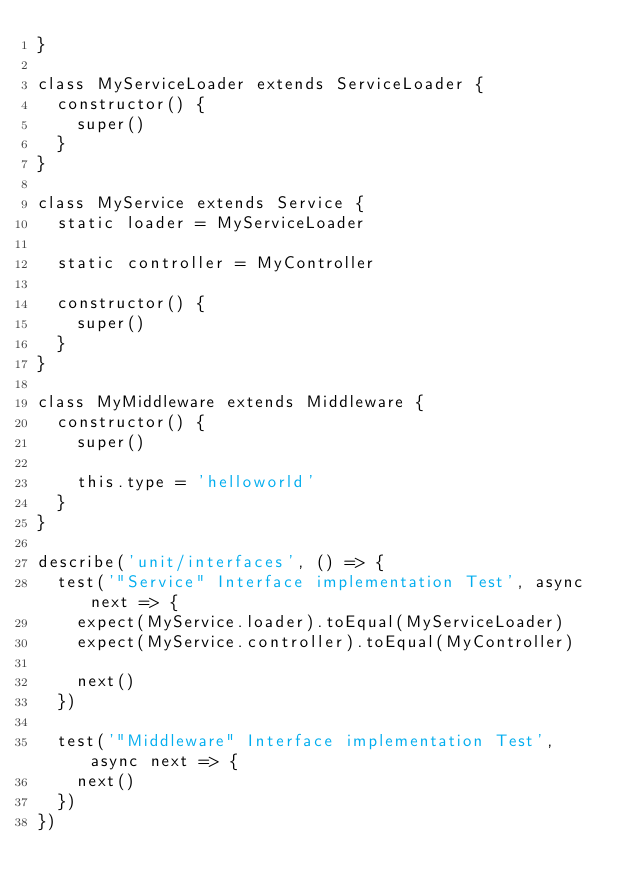<code> <loc_0><loc_0><loc_500><loc_500><_JavaScript_>}

class MyServiceLoader extends ServiceLoader {
  constructor() {
    super()
  }
}

class MyService extends Service {
  static loader = MyServiceLoader

  static controller = MyController

  constructor() {
    super()
  }
}

class MyMiddleware extends Middleware {
  constructor() {
    super()

    this.type = 'helloworld'
  }
}

describe('unit/interfaces', () => {
  test('"Service" Interface implementation Test', async next => {
    expect(MyService.loader).toEqual(MyServiceLoader)
    expect(MyService.controller).toEqual(MyController)

    next()
  })

  test('"Middleware" Interface implementation Test', async next => {
    next()
  })
})
</code> 